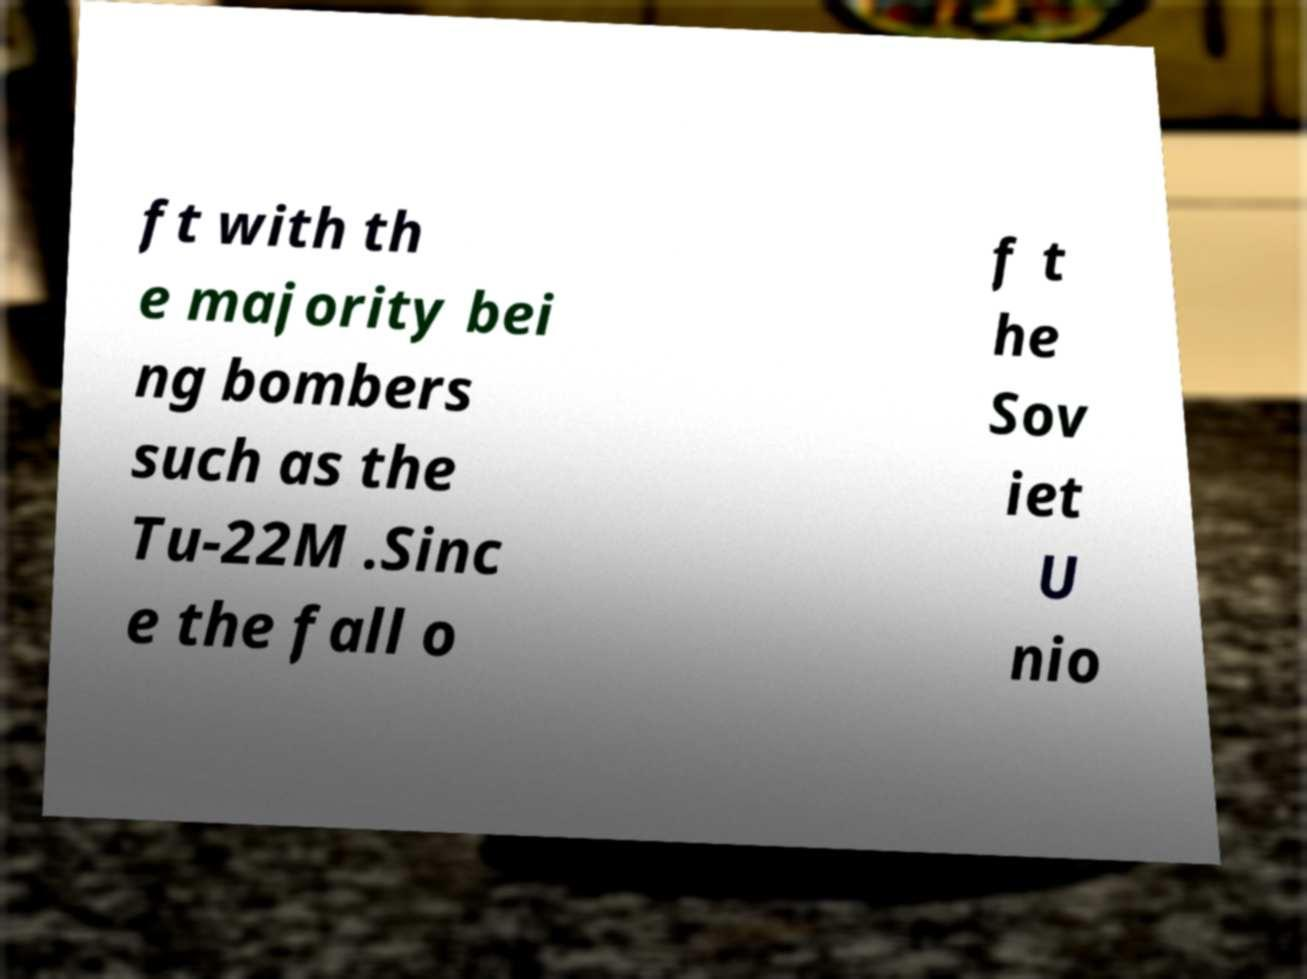Could you extract and type out the text from this image? ft with th e majority bei ng bombers such as the Tu-22M .Sinc e the fall o f t he Sov iet U nio 